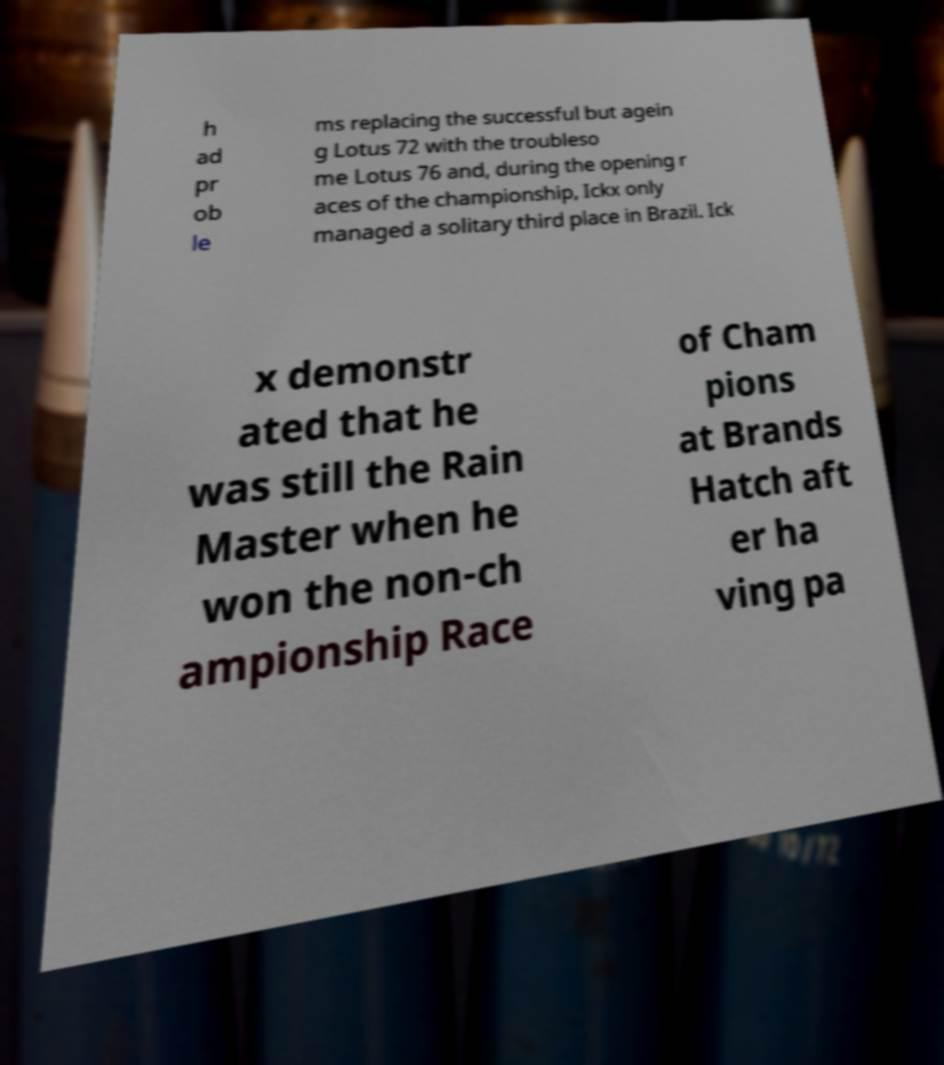Please identify and transcribe the text found in this image. h ad pr ob le ms replacing the successful but agein g Lotus 72 with the troubleso me Lotus 76 and, during the opening r aces of the championship, Ickx only managed a solitary third place in Brazil. Ick x demonstr ated that he was still the Rain Master when he won the non-ch ampionship Race of Cham pions at Brands Hatch aft er ha ving pa 